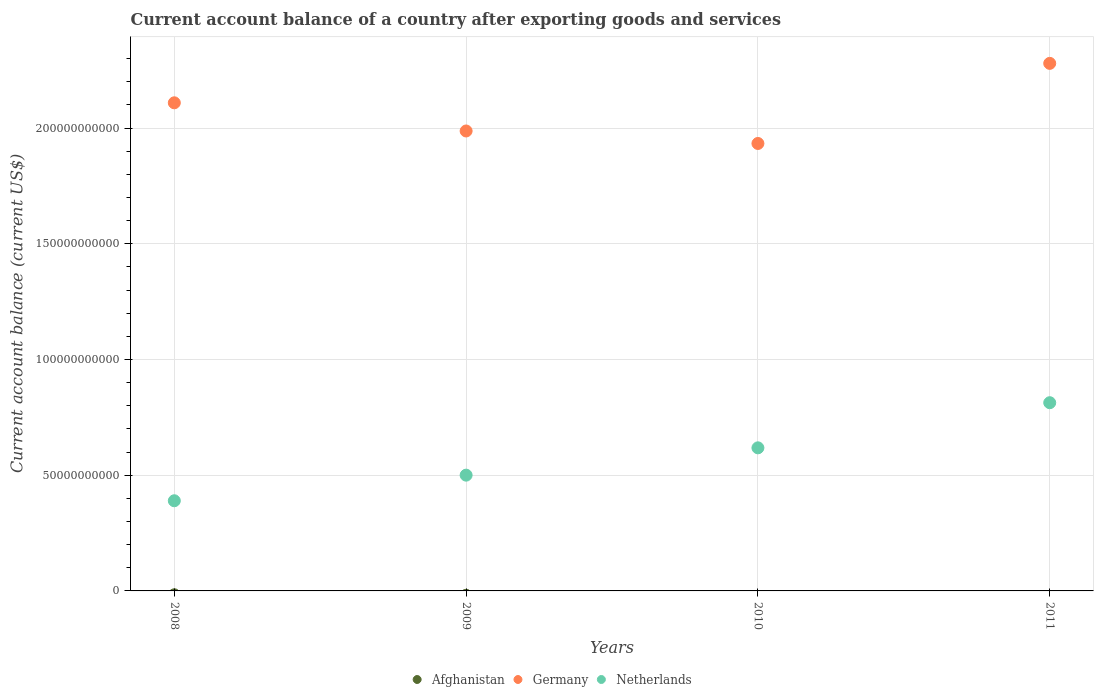Across all years, what is the maximum account balance in Netherlands?
Your answer should be very brief. 8.13e+1. Across all years, what is the minimum account balance in Germany?
Make the answer very short. 1.93e+11. In which year was the account balance in Germany maximum?
Offer a terse response. 2011. What is the total account balance in Germany in the graph?
Provide a short and direct response. 8.31e+11. What is the difference between the account balance in Germany in 2008 and that in 2009?
Make the answer very short. 1.22e+1. What is the difference between the account balance in Germany in 2010 and the account balance in Afghanistan in 2009?
Provide a succinct answer. 1.93e+11. What is the average account balance in Netherlands per year?
Give a very brief answer. 5.80e+1. In the year 2010, what is the difference between the account balance in Germany and account balance in Netherlands?
Your response must be concise. 1.32e+11. In how many years, is the account balance in Afghanistan greater than 10000000000 US$?
Offer a very short reply. 0. What is the ratio of the account balance in Netherlands in 2008 to that in 2010?
Your response must be concise. 0.63. Is the account balance in Germany in 2008 less than that in 2009?
Your answer should be very brief. No. Is the difference between the account balance in Germany in 2008 and 2010 greater than the difference between the account balance in Netherlands in 2008 and 2010?
Provide a short and direct response. Yes. What is the difference between the highest and the second highest account balance in Netherlands?
Keep it short and to the point. 1.95e+1. What is the difference between the highest and the lowest account balance in Germany?
Give a very brief answer. 3.46e+1. Is it the case that in every year, the sum of the account balance in Netherlands and account balance in Afghanistan  is greater than the account balance in Germany?
Your response must be concise. No. Is the account balance in Germany strictly greater than the account balance in Afghanistan over the years?
Offer a terse response. Yes. Is the account balance in Germany strictly less than the account balance in Netherlands over the years?
Make the answer very short. No. Are the values on the major ticks of Y-axis written in scientific E-notation?
Provide a short and direct response. No. Does the graph contain grids?
Your answer should be very brief. Yes. How are the legend labels stacked?
Offer a terse response. Horizontal. What is the title of the graph?
Your response must be concise. Current account balance of a country after exporting goods and services. What is the label or title of the X-axis?
Your answer should be very brief. Years. What is the label or title of the Y-axis?
Keep it short and to the point. Current account balance (current US$). What is the Current account balance (current US$) of Afghanistan in 2008?
Provide a short and direct response. 0. What is the Current account balance (current US$) in Germany in 2008?
Your response must be concise. 2.11e+11. What is the Current account balance (current US$) of Netherlands in 2008?
Offer a very short reply. 3.90e+1. What is the Current account balance (current US$) of Afghanistan in 2009?
Your answer should be very brief. 0. What is the Current account balance (current US$) in Germany in 2009?
Offer a terse response. 1.99e+11. What is the Current account balance (current US$) of Netherlands in 2009?
Provide a short and direct response. 5.00e+1. What is the Current account balance (current US$) of Germany in 2010?
Ensure brevity in your answer.  1.93e+11. What is the Current account balance (current US$) in Netherlands in 2010?
Keep it short and to the point. 6.18e+1. What is the Current account balance (current US$) in Afghanistan in 2011?
Give a very brief answer. 0. What is the Current account balance (current US$) in Germany in 2011?
Ensure brevity in your answer.  2.28e+11. What is the Current account balance (current US$) in Netherlands in 2011?
Your response must be concise. 8.13e+1. Across all years, what is the maximum Current account balance (current US$) of Germany?
Your answer should be very brief. 2.28e+11. Across all years, what is the maximum Current account balance (current US$) in Netherlands?
Offer a terse response. 8.13e+1. Across all years, what is the minimum Current account balance (current US$) of Germany?
Provide a succinct answer. 1.93e+11. Across all years, what is the minimum Current account balance (current US$) of Netherlands?
Make the answer very short. 3.90e+1. What is the total Current account balance (current US$) of Afghanistan in the graph?
Keep it short and to the point. 0. What is the total Current account balance (current US$) of Germany in the graph?
Give a very brief answer. 8.31e+11. What is the total Current account balance (current US$) of Netherlands in the graph?
Make the answer very short. 2.32e+11. What is the difference between the Current account balance (current US$) of Germany in 2008 and that in 2009?
Your answer should be very brief. 1.22e+1. What is the difference between the Current account balance (current US$) in Netherlands in 2008 and that in 2009?
Ensure brevity in your answer.  -1.11e+1. What is the difference between the Current account balance (current US$) in Germany in 2008 and that in 2010?
Offer a terse response. 1.76e+1. What is the difference between the Current account balance (current US$) in Netherlands in 2008 and that in 2010?
Give a very brief answer. -2.29e+1. What is the difference between the Current account balance (current US$) of Germany in 2008 and that in 2011?
Your answer should be compact. -1.70e+1. What is the difference between the Current account balance (current US$) of Netherlands in 2008 and that in 2011?
Provide a short and direct response. -4.24e+1. What is the difference between the Current account balance (current US$) in Germany in 2009 and that in 2010?
Offer a terse response. 5.40e+09. What is the difference between the Current account balance (current US$) in Netherlands in 2009 and that in 2010?
Offer a terse response. -1.18e+1. What is the difference between the Current account balance (current US$) of Germany in 2009 and that in 2011?
Ensure brevity in your answer.  -2.92e+1. What is the difference between the Current account balance (current US$) in Netherlands in 2009 and that in 2011?
Make the answer very short. -3.13e+1. What is the difference between the Current account balance (current US$) in Germany in 2010 and that in 2011?
Provide a succinct answer. -3.46e+1. What is the difference between the Current account balance (current US$) of Netherlands in 2010 and that in 2011?
Give a very brief answer. -1.95e+1. What is the difference between the Current account balance (current US$) of Germany in 2008 and the Current account balance (current US$) of Netherlands in 2009?
Your answer should be compact. 1.61e+11. What is the difference between the Current account balance (current US$) of Germany in 2008 and the Current account balance (current US$) of Netherlands in 2010?
Provide a succinct answer. 1.49e+11. What is the difference between the Current account balance (current US$) in Germany in 2008 and the Current account balance (current US$) in Netherlands in 2011?
Your answer should be compact. 1.30e+11. What is the difference between the Current account balance (current US$) of Germany in 2009 and the Current account balance (current US$) of Netherlands in 2010?
Make the answer very short. 1.37e+11. What is the difference between the Current account balance (current US$) in Germany in 2009 and the Current account balance (current US$) in Netherlands in 2011?
Give a very brief answer. 1.17e+11. What is the difference between the Current account balance (current US$) of Germany in 2010 and the Current account balance (current US$) of Netherlands in 2011?
Give a very brief answer. 1.12e+11. What is the average Current account balance (current US$) of Afghanistan per year?
Provide a succinct answer. 0. What is the average Current account balance (current US$) of Germany per year?
Offer a very short reply. 2.08e+11. What is the average Current account balance (current US$) in Netherlands per year?
Give a very brief answer. 5.80e+1. In the year 2008, what is the difference between the Current account balance (current US$) in Germany and Current account balance (current US$) in Netherlands?
Give a very brief answer. 1.72e+11. In the year 2009, what is the difference between the Current account balance (current US$) in Germany and Current account balance (current US$) in Netherlands?
Your answer should be very brief. 1.49e+11. In the year 2010, what is the difference between the Current account balance (current US$) of Germany and Current account balance (current US$) of Netherlands?
Ensure brevity in your answer.  1.32e+11. In the year 2011, what is the difference between the Current account balance (current US$) in Germany and Current account balance (current US$) in Netherlands?
Offer a terse response. 1.47e+11. What is the ratio of the Current account balance (current US$) of Germany in 2008 to that in 2009?
Provide a short and direct response. 1.06. What is the ratio of the Current account balance (current US$) in Netherlands in 2008 to that in 2009?
Ensure brevity in your answer.  0.78. What is the ratio of the Current account balance (current US$) of Netherlands in 2008 to that in 2010?
Make the answer very short. 0.63. What is the ratio of the Current account balance (current US$) in Germany in 2008 to that in 2011?
Provide a short and direct response. 0.93. What is the ratio of the Current account balance (current US$) of Netherlands in 2008 to that in 2011?
Keep it short and to the point. 0.48. What is the ratio of the Current account balance (current US$) of Germany in 2009 to that in 2010?
Ensure brevity in your answer.  1.03. What is the ratio of the Current account balance (current US$) of Netherlands in 2009 to that in 2010?
Ensure brevity in your answer.  0.81. What is the ratio of the Current account balance (current US$) of Germany in 2009 to that in 2011?
Your answer should be very brief. 0.87. What is the ratio of the Current account balance (current US$) of Netherlands in 2009 to that in 2011?
Keep it short and to the point. 0.62. What is the ratio of the Current account balance (current US$) of Germany in 2010 to that in 2011?
Provide a succinct answer. 0.85. What is the ratio of the Current account balance (current US$) of Netherlands in 2010 to that in 2011?
Your answer should be compact. 0.76. What is the difference between the highest and the second highest Current account balance (current US$) in Germany?
Provide a succinct answer. 1.70e+1. What is the difference between the highest and the second highest Current account balance (current US$) of Netherlands?
Ensure brevity in your answer.  1.95e+1. What is the difference between the highest and the lowest Current account balance (current US$) in Germany?
Provide a short and direct response. 3.46e+1. What is the difference between the highest and the lowest Current account balance (current US$) of Netherlands?
Your answer should be very brief. 4.24e+1. 